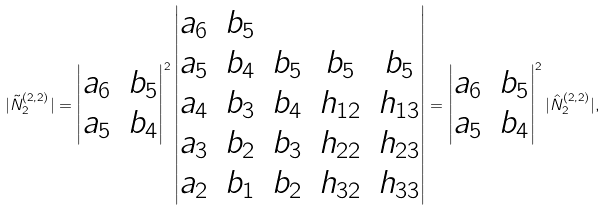Convert formula to latex. <formula><loc_0><loc_0><loc_500><loc_500>| \tilde { N } ^ { ( 2 , 2 ) } _ { 2 } | = \begin{vmatrix} a _ { 6 } & b _ { 5 } \\ a _ { 5 } & b _ { 4 } \end{vmatrix} ^ { 2 } \begin{vmatrix} a _ { 6 } & b _ { 5 } & \\ a _ { 5 } & b _ { 4 } & b _ { 5 } & b _ { 5 } & b _ { 5 } \\ a _ { 4 } & b _ { 3 } & b _ { 4 } & h _ { 1 2 } & h _ { 1 3 } \\ a _ { 3 } & b _ { 2 } & b _ { 3 } & h _ { 2 2 } & h _ { 2 3 } \\ a _ { 2 } & b _ { 1 } & b _ { 2 } & h _ { 3 2 } & h _ { 3 3 } \end{vmatrix} = \begin{vmatrix} a _ { 6 } & b _ { 5 } \\ a _ { 5 } & b _ { 4 } \end{vmatrix} ^ { 2 } | \hat { N } ^ { ( 2 , 2 ) } _ { 2 } | ,</formula> 